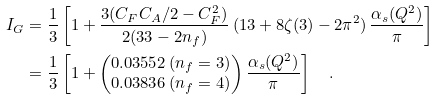<formula> <loc_0><loc_0><loc_500><loc_500>I _ { G } & = \frac { 1 } { 3 } \left [ 1 + \frac { 3 ( C _ { F } C _ { A } / 2 - C _ { F } ^ { 2 } ) } { 2 ( 3 3 - 2 n _ { f } ) } \, ( 1 3 + 8 \zeta ( 3 ) - 2 \pi ^ { 2 } ) \, \frac { \alpha _ { s } ( Q ^ { 2 } ) } { \pi } \right ] \\ & = \frac { 1 } { 3 } \left [ 1 + \begin{pmatrix} 0 . 0 3 5 5 2 \, ( n _ { f } = 3 ) \\ 0 . 0 3 8 3 6 \, ( n _ { f } = 4 ) \end{pmatrix} \frac { \alpha _ { s } ( Q ^ { 2 } ) } { \pi } \right ] \quad .</formula> 